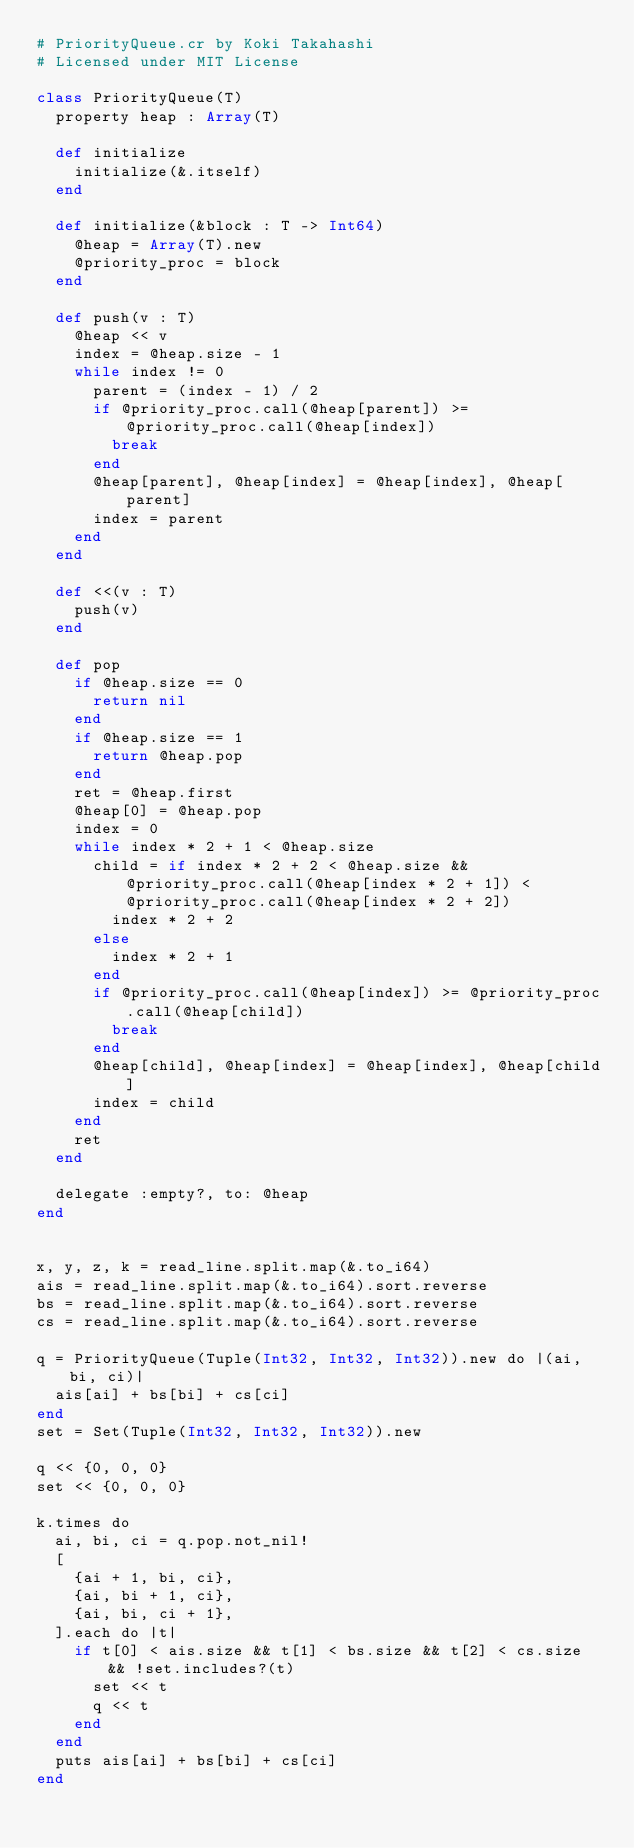Convert code to text. <code><loc_0><loc_0><loc_500><loc_500><_Crystal_># PriorityQueue.cr by Koki Takahashi
# Licensed under MIT License

class PriorityQueue(T)
  property heap : Array(T)

  def initialize
    initialize(&.itself)
  end

  def initialize(&block : T -> Int64)
    @heap = Array(T).new
    @priority_proc = block
  end

  def push(v : T)
    @heap << v
    index = @heap.size - 1
    while index != 0
      parent = (index - 1) / 2
      if @priority_proc.call(@heap[parent]) >= @priority_proc.call(@heap[index])
        break
      end
      @heap[parent], @heap[index] = @heap[index], @heap[parent]
      index = parent
    end
  end

  def <<(v : T)
    push(v)
  end

  def pop
    if @heap.size == 0
      return nil
    end
    if @heap.size == 1
      return @heap.pop
    end
    ret = @heap.first
    @heap[0] = @heap.pop
    index = 0
    while index * 2 + 1 < @heap.size
      child = if index * 2 + 2 < @heap.size && @priority_proc.call(@heap[index * 2 + 1]) < @priority_proc.call(@heap[index * 2 + 2])
        index * 2 + 2
      else
        index * 2 + 1
      end
      if @priority_proc.call(@heap[index]) >= @priority_proc.call(@heap[child])
        break
      end
      @heap[child], @heap[index] = @heap[index], @heap[child]
      index = child
    end
    ret
  end

  delegate :empty?, to: @heap
end


x, y, z, k = read_line.split.map(&.to_i64)
ais = read_line.split.map(&.to_i64).sort.reverse
bs = read_line.split.map(&.to_i64).sort.reverse
cs = read_line.split.map(&.to_i64).sort.reverse

q = PriorityQueue(Tuple(Int32, Int32, Int32)).new do |(ai, bi, ci)|
  ais[ai] + bs[bi] + cs[ci]
end
set = Set(Tuple(Int32, Int32, Int32)).new

q << {0, 0, 0}
set << {0, 0, 0}

k.times do
  ai, bi, ci = q.pop.not_nil!
  [
    {ai + 1, bi, ci},
    {ai, bi + 1, ci},
    {ai, bi, ci + 1},
  ].each do |t|
    if t[0] < ais.size && t[1] < bs.size && t[2] < cs.size && !set.includes?(t)
      set << t
      q << t
    end
  end
  puts ais[ai] + bs[bi] + cs[ci]
end</code> 